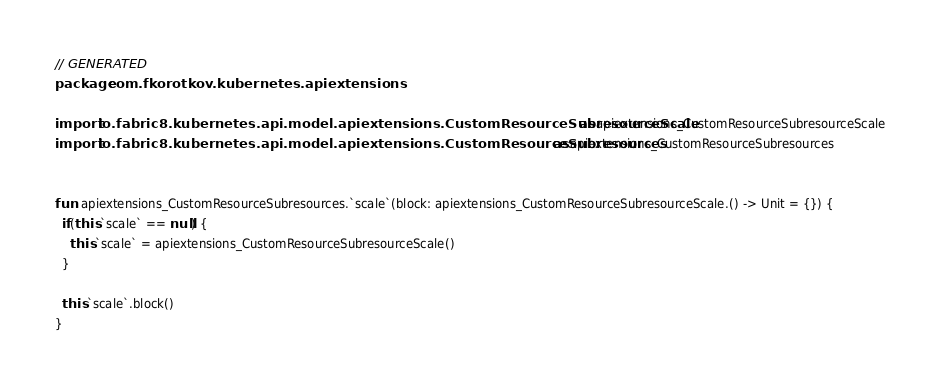Convert code to text. <code><loc_0><loc_0><loc_500><loc_500><_Kotlin_>// GENERATED
package com.fkorotkov.kubernetes.apiextensions

import io.fabric8.kubernetes.api.model.apiextensions.CustomResourceSubresourceScale as apiextensions_CustomResourceSubresourceScale
import io.fabric8.kubernetes.api.model.apiextensions.CustomResourceSubresources as apiextensions_CustomResourceSubresources


fun  apiextensions_CustomResourceSubresources.`scale`(block: apiextensions_CustomResourceSubresourceScale.() -> Unit = {}) {
  if(this.`scale` == null) {
    this.`scale` = apiextensions_CustomResourceSubresourceScale()
  }

  this.`scale`.block()
}

</code> 